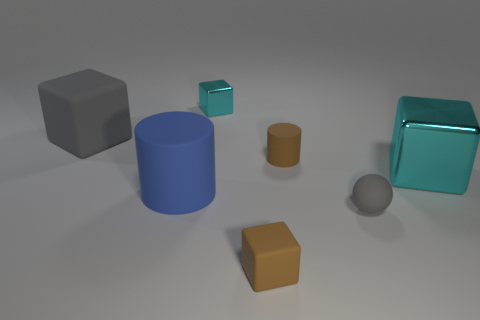Subtract all big gray blocks. How many blocks are left? 3 Subtract 1 blocks. How many blocks are left? 3 Subtract all blue balls. How many cyan blocks are left? 2 Add 2 big brown matte blocks. How many objects exist? 9 Subtract all gray blocks. How many blocks are left? 3 Subtract all gray cubes. Subtract all gray spheres. How many cubes are left? 3 Subtract all balls. How many objects are left? 6 Subtract all gray rubber blocks. Subtract all cyan metallic blocks. How many objects are left? 4 Add 3 matte balls. How many matte balls are left? 4 Add 7 tiny rubber objects. How many tiny rubber objects exist? 10 